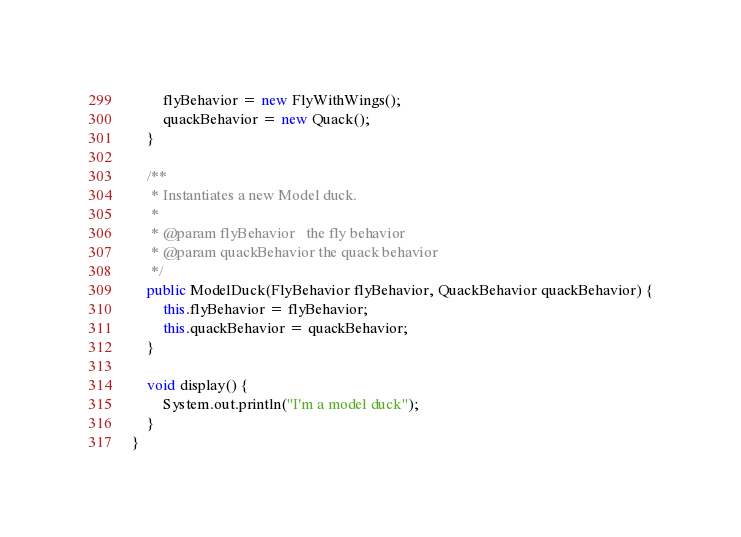Convert code to text. <code><loc_0><loc_0><loc_500><loc_500><_Java_>        flyBehavior = new FlyWithWings();
        quackBehavior = new Quack();
    }

    /**
     * Instantiates a new Model duck.
     *
     * @param flyBehavior   the fly behavior
     * @param quackBehavior the quack behavior
     */
    public ModelDuck(FlyBehavior flyBehavior, QuackBehavior quackBehavior) {
        this.flyBehavior = flyBehavior;
        this.quackBehavior = quackBehavior;
    }

    void display() {
        System.out.println("I'm a model duck");
    }
}
</code> 